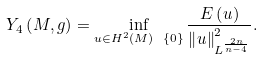<formula> <loc_0><loc_0><loc_500><loc_500>Y _ { 4 } \left ( M , g \right ) = \inf _ { u \in H ^ { 2 } \left ( M \right ) \ \left \{ 0 \right \} } \frac { E \left ( u \right ) } { \left \| u \right \| _ { L ^ { \frac { 2 n } { n - 4 } } } ^ { 2 } } .</formula> 